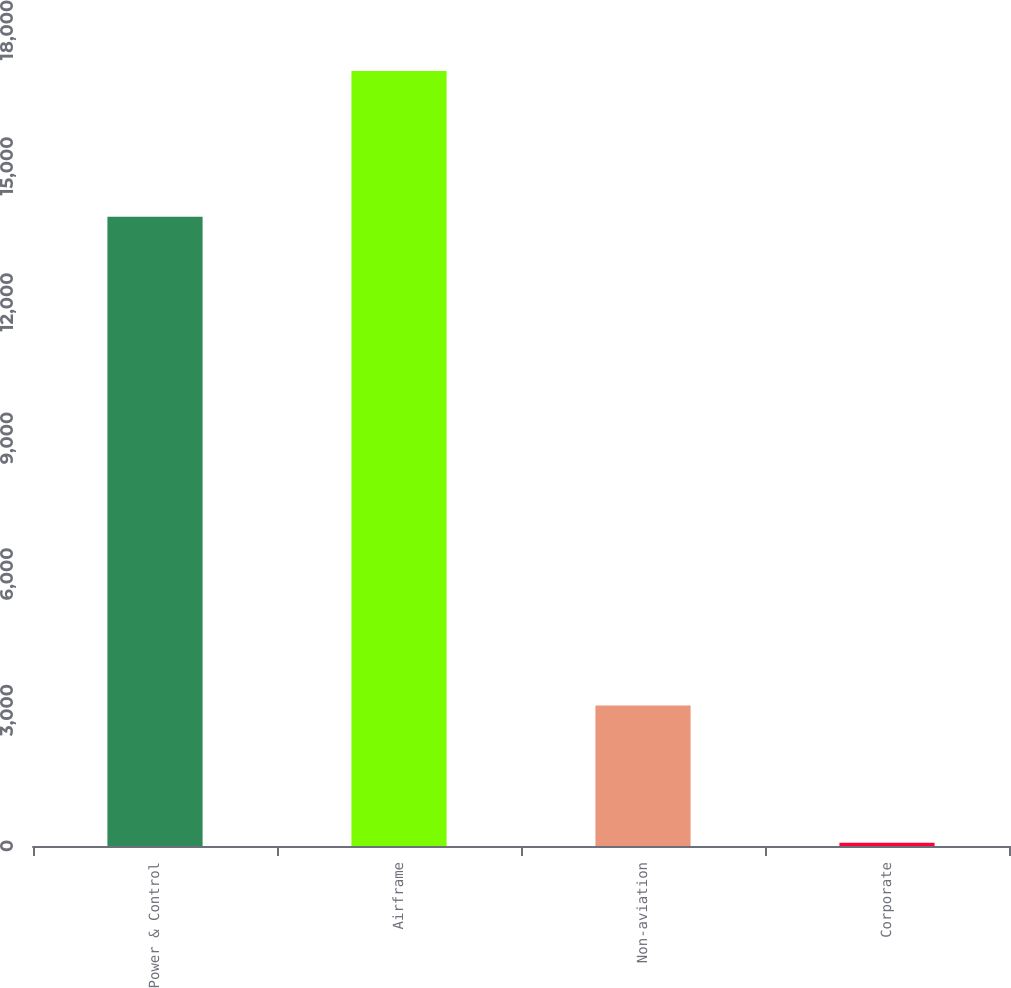Convert chart to OTSL. <chart><loc_0><loc_0><loc_500><loc_500><bar_chart><fcel>Power & Control<fcel>Airframe<fcel>Non-aviation<fcel>Corporate<nl><fcel>13882<fcel>17096<fcel>3097<fcel>71<nl></chart> 